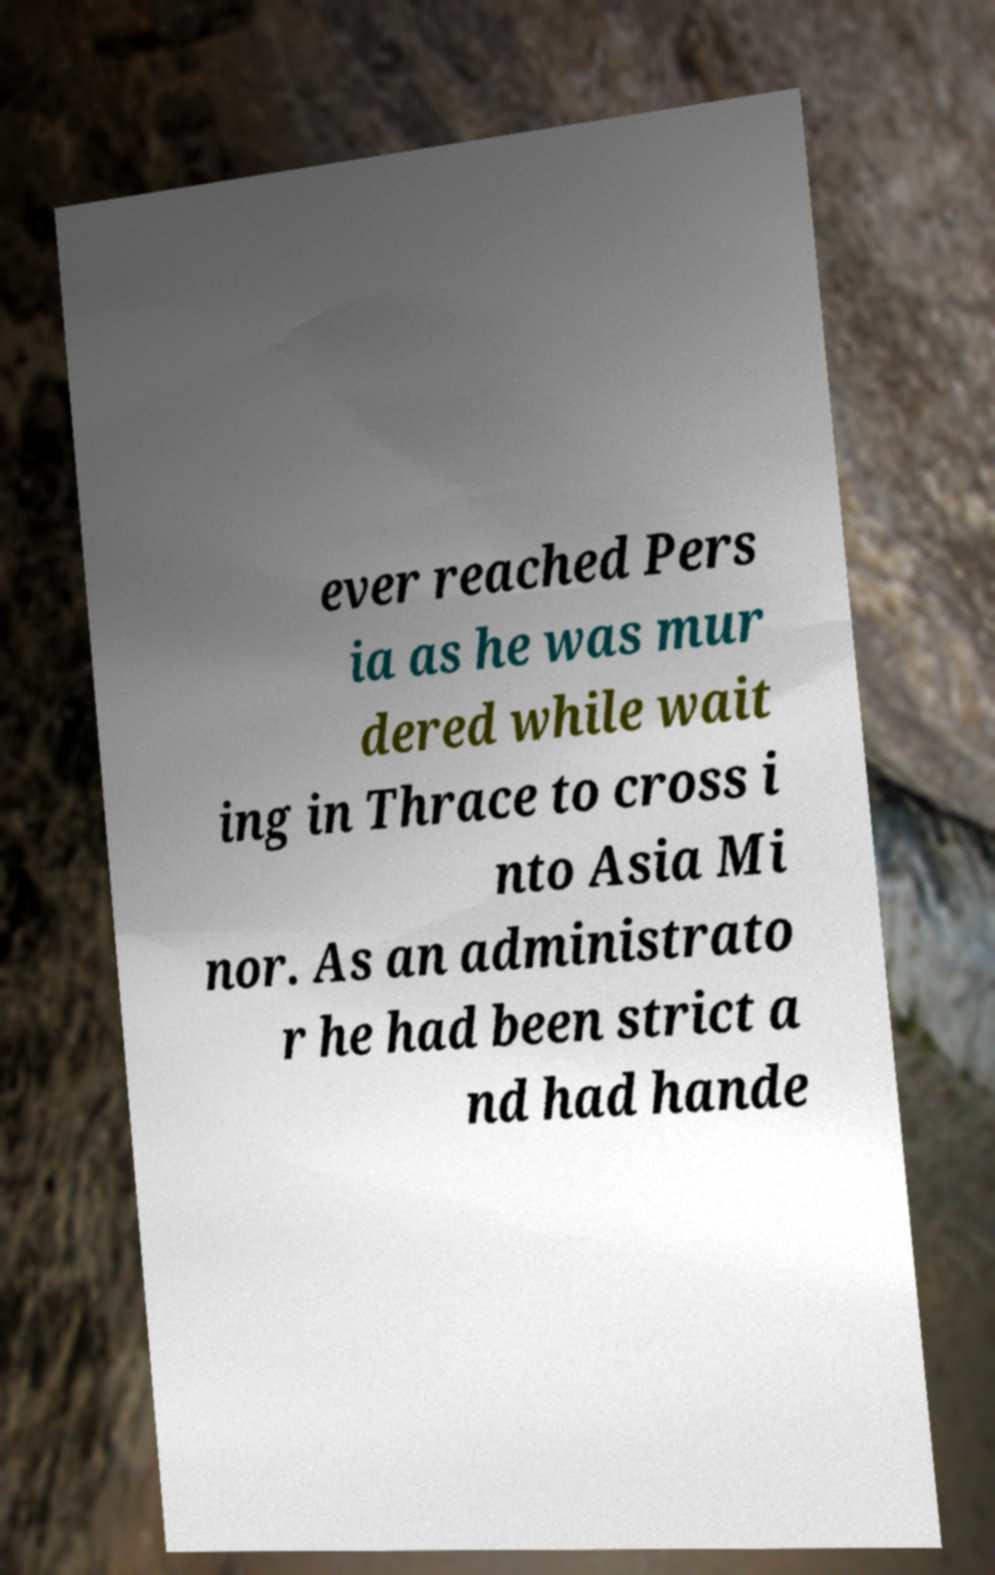Can you accurately transcribe the text from the provided image for me? ever reached Pers ia as he was mur dered while wait ing in Thrace to cross i nto Asia Mi nor. As an administrato r he had been strict a nd had hande 